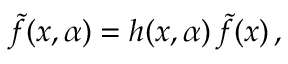Convert formula to latex. <formula><loc_0><loc_0><loc_500><loc_500>\tilde { f } ( x , \alpha ) = h ( x , \alpha ) \, \tilde { f } ( x ) \, ,</formula> 